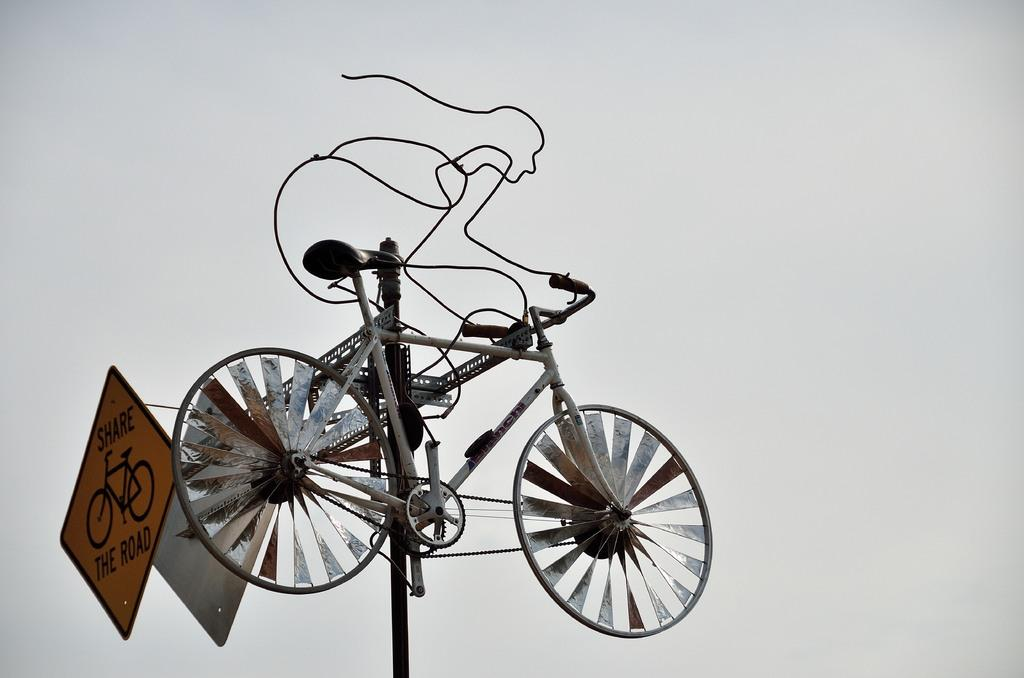What is placed on top of the pole in the image? There is a bicycle on a pole in the image. Are there any additional objects on the pole? Yes, there are two small boards and metal items on the pole. What can be seen in the background of the image? The background of the image is empty or contains no significant elements. Can you see any cherries growing on the pole in the image? There are no cherries present in the image; the pole contains a bicycle, small boards, and metal items. Is there a bubble floating near the bicycle in the image? There is no bubble visible in the image; it features a bicycle, small boards, and metal items on a pole. 